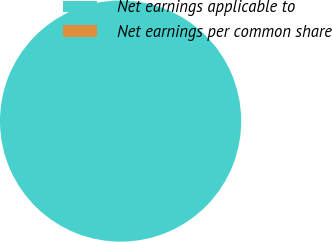Convert chart. <chart><loc_0><loc_0><loc_500><loc_500><pie_chart><fcel>Net earnings applicable to<fcel>Net earnings per common share<nl><fcel>100.0%<fcel>0.0%<nl></chart> 